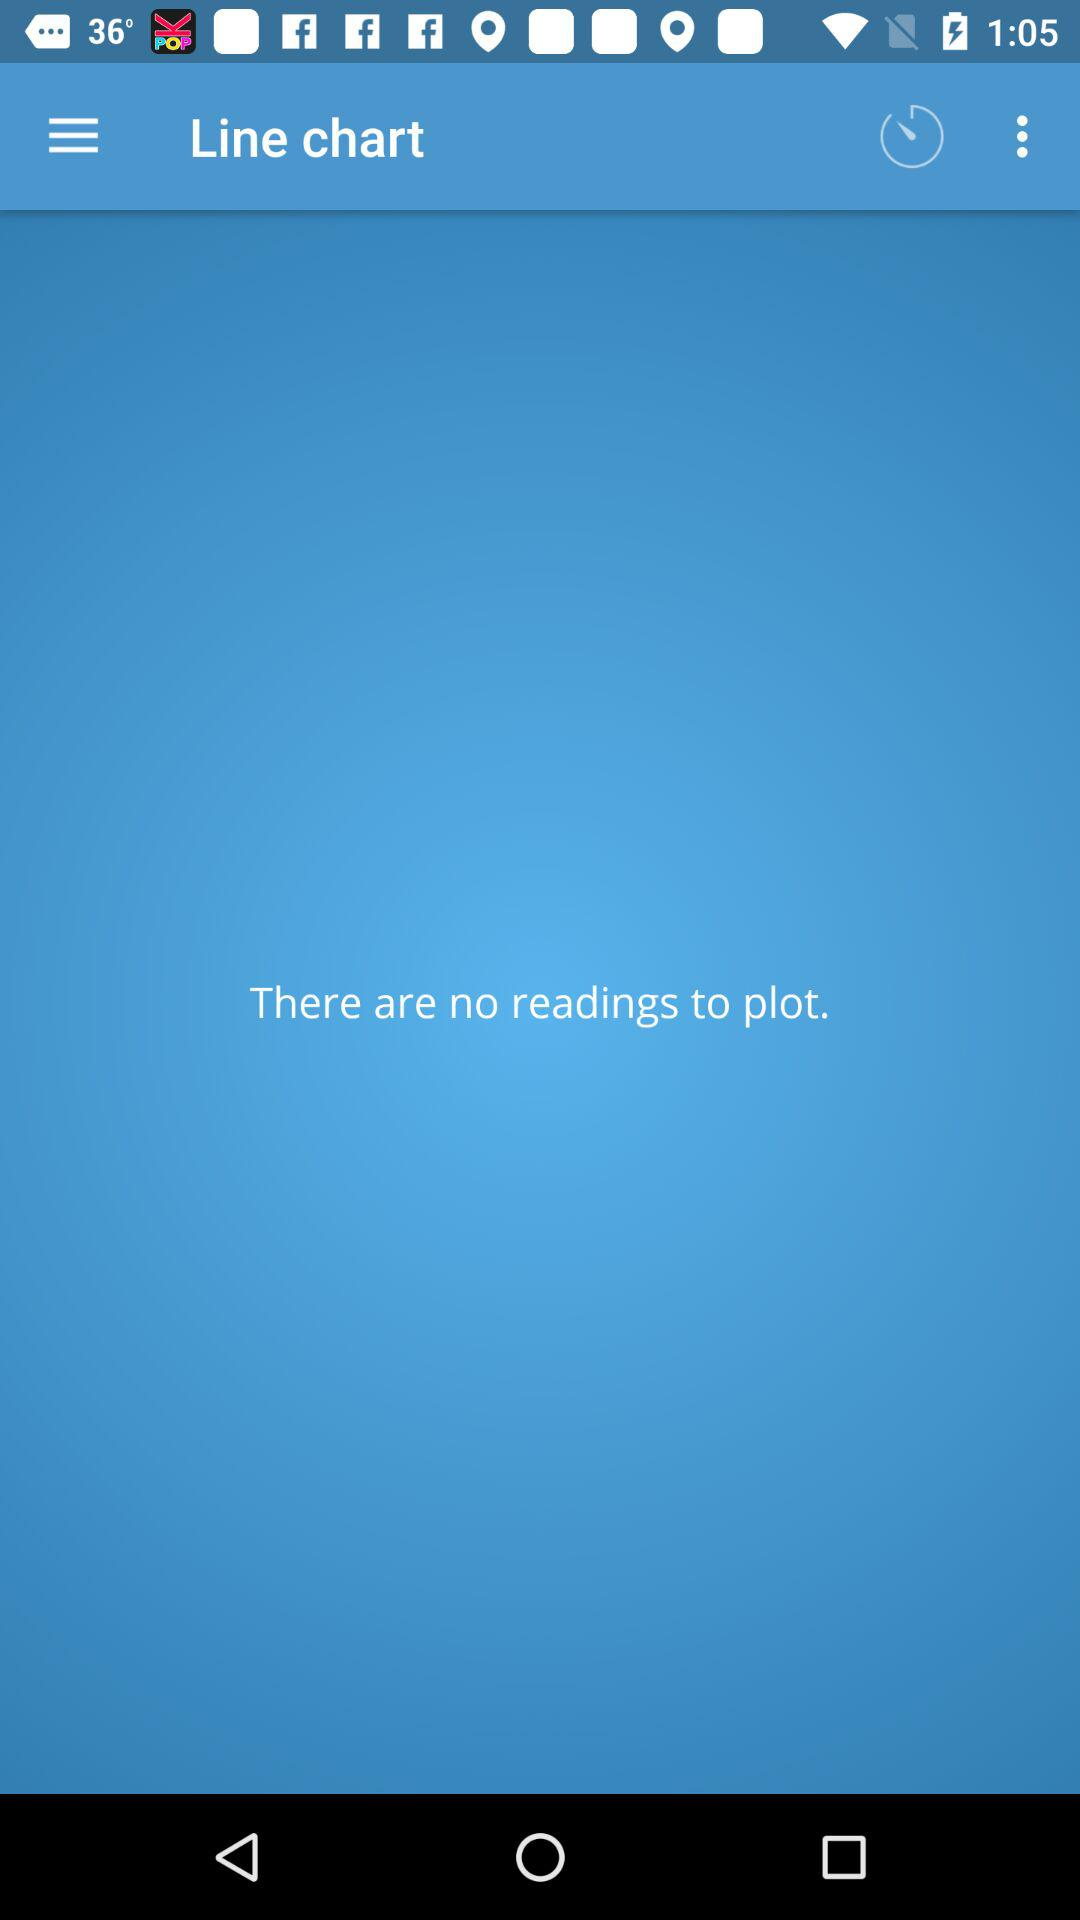Are there any readings to plot? There are no readings to plot. 